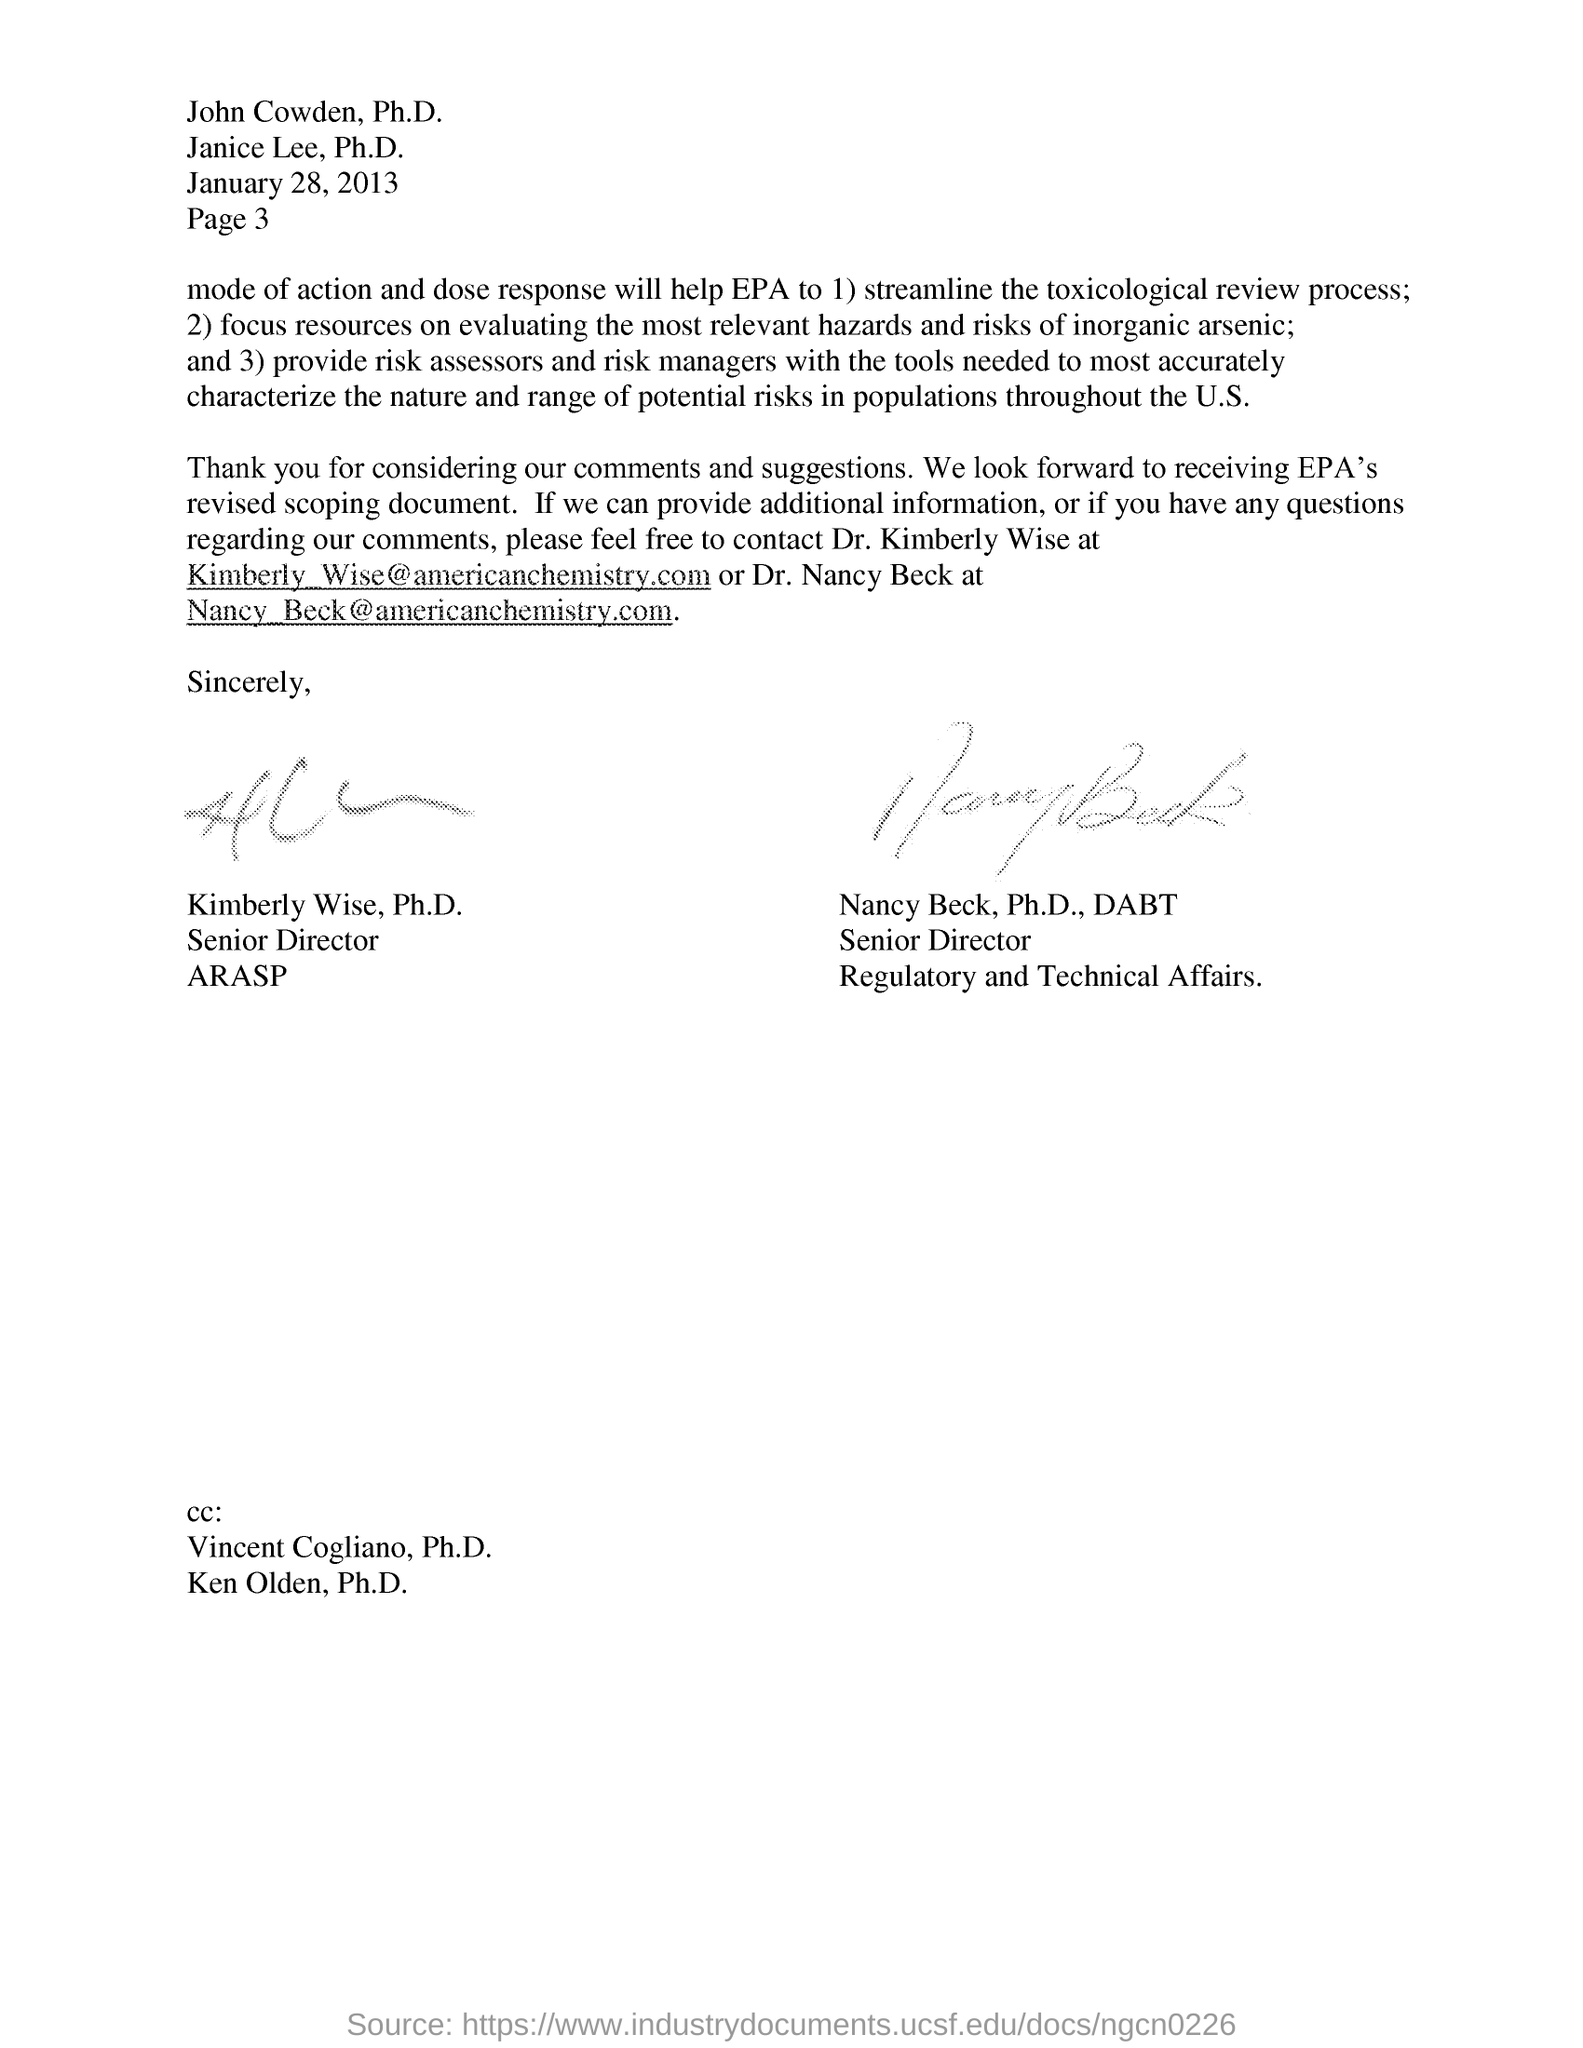Mention the email id of dr. kimberly wise email id ?
Provide a short and direct response. Kimberly_Wise@americanchemistry.com. Who is senior director for arasp in this letter?
Ensure brevity in your answer.  KIMBERLY WISE. Mention the first name in the CC?
Provide a succinct answer. Vincent cogliano, ph.d. 